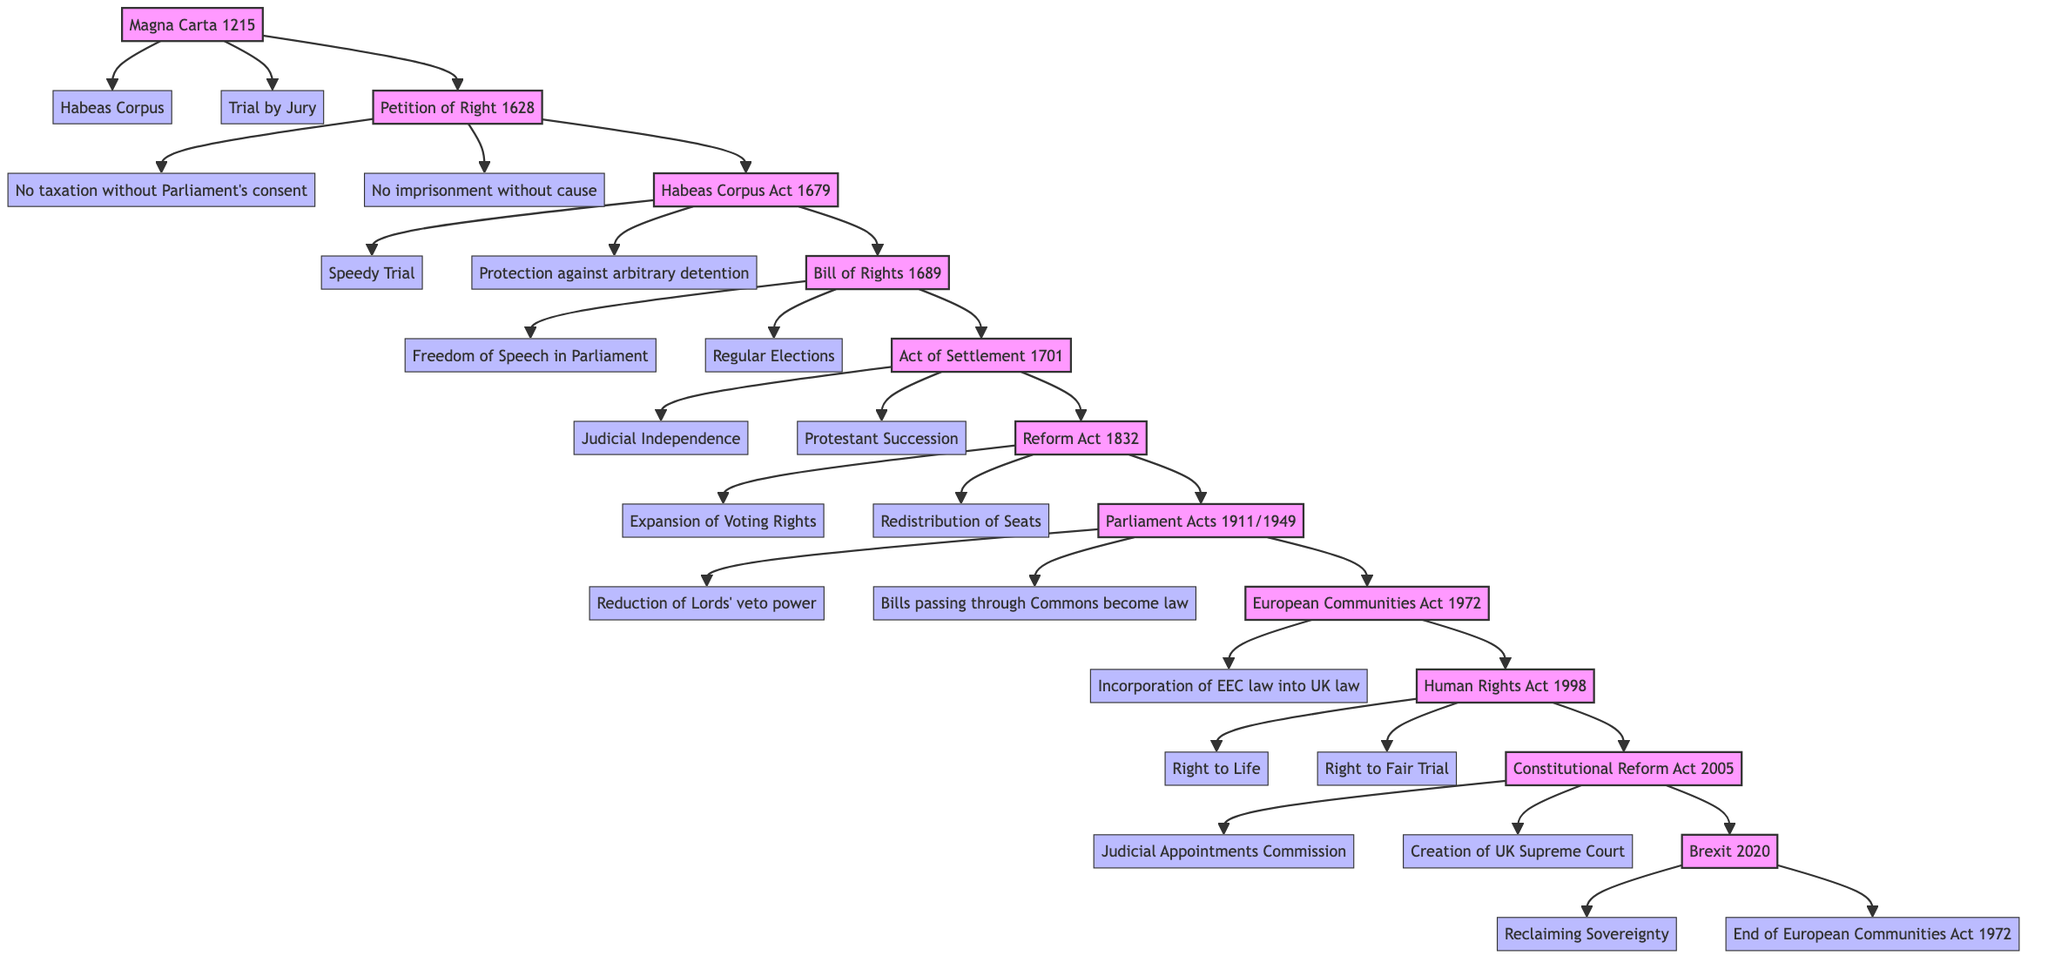What is the earliest document in the family tree? The earliest document listed is the Magna Carta, which is positioned at the top of the family tree, indicating its foundational status in the evolution of British constitutional law.
Answer: Magna Carta How many important provisions are associated with the Bill of Rights? The Bill of Rights has two important provisions connected to it, which can be seen represented as branches stemming from the Bill of Rights node.
Answer: 2 Which Act introduced reforms to the electoral system? The Reform Act is specifically highlighted in the family tree as the document that introduced major changes to the electoral system, making it clear that this act was pivotal for electoral reforms.
Answer: Reform Act What year was the Human Rights Act enacted? The Human Rights Act is placed in the tree under its node with the year 1998, clearly indicated next to it, providing straightforward information about its enactment year.
Answer: 1998 Which provision is related to the Parliament Acts? The Parliament Acts are directly connected with two provisions: "Reduction of Lords' veto power" and "Bills passing through Commons become law," demonstrating the significance of these changes in parliamentary procedures.
Answer: Reduction of Lords' veto power Which event signifies the end of the European Communities Act? The last node in the tree is Brexit, which is clearly labeled with the significant provision "End of European Communities Act 1972," marking its importance in relation to the act's termination.
Answer: Brexit How many events are depicted in total within the family tree? By counting all the individual event nodes in the family tree, including the Parliament Acts as a single node, a total of eleven nodes can be identified, denoting distinct historical milestones in British constitutional law.
Answer: 11 What does the Act of Settlement address? The Act of Settlement is linked to two important provisions: "Judicial Independence" and "Protestant Succession," indicating that it plays a role in governing issues of succession and the judiciary.
Answer: Judicial Independence What provision does the Habeas Corpus Act enhance? The Habeas Corpus Act is connected to provisions that promote "Speedy Trial" and "Protection against arbitrary detention," underscoring its role in ensuring legal protections for individuals in custody.
Answer: Speedy Trial 